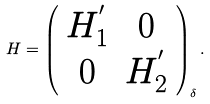<formula> <loc_0><loc_0><loc_500><loc_500>H = \left ( \begin{array} { c c } H _ { 1 } ^ { ^ { \prime } } & 0 \\ 0 & H _ { 2 } ^ { ^ { \prime } } \end{array} \right ) _ { \delta } .</formula> 